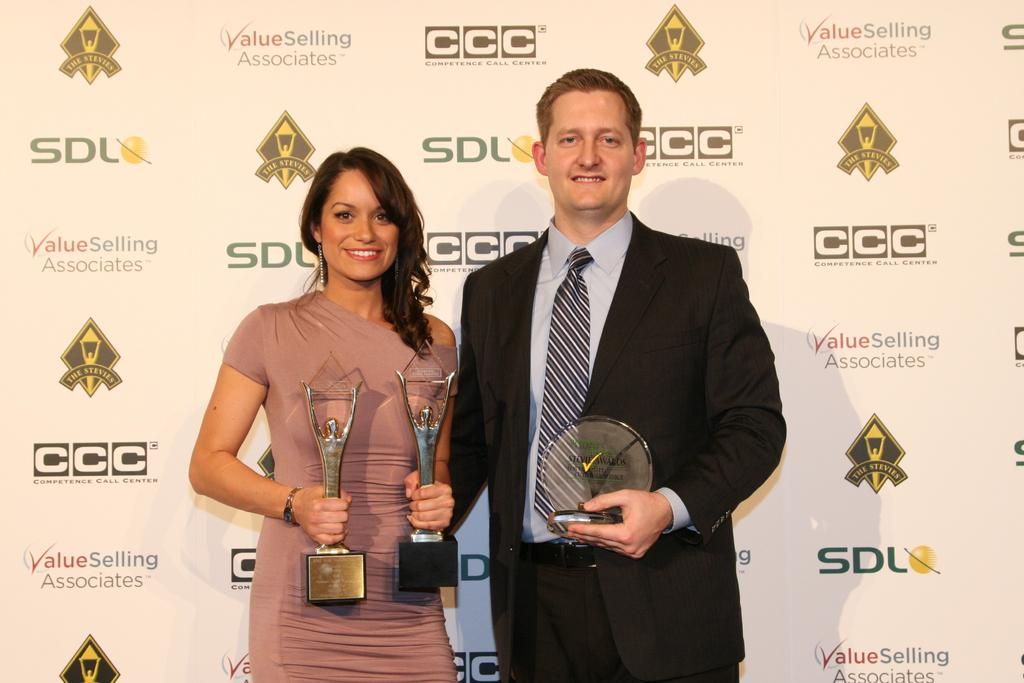Who or what can be seen in the image? There are people in the image. What are the people doing in the image? The people are holding objects. What can be seen in the background of the image? There is a board in the background of the image. What is on the board in the image? The board has images and text on it. Can you tell me how many glasses of juice are on the table in the image? There is no mention of juice or glasses in the provided facts, so it cannot be determined from the image. 